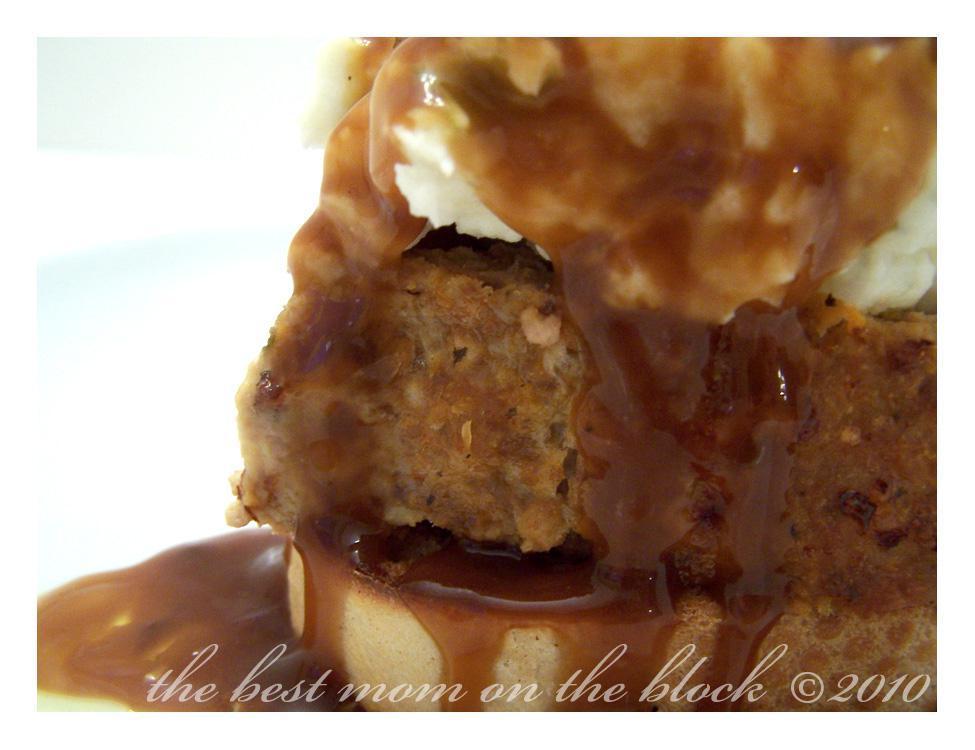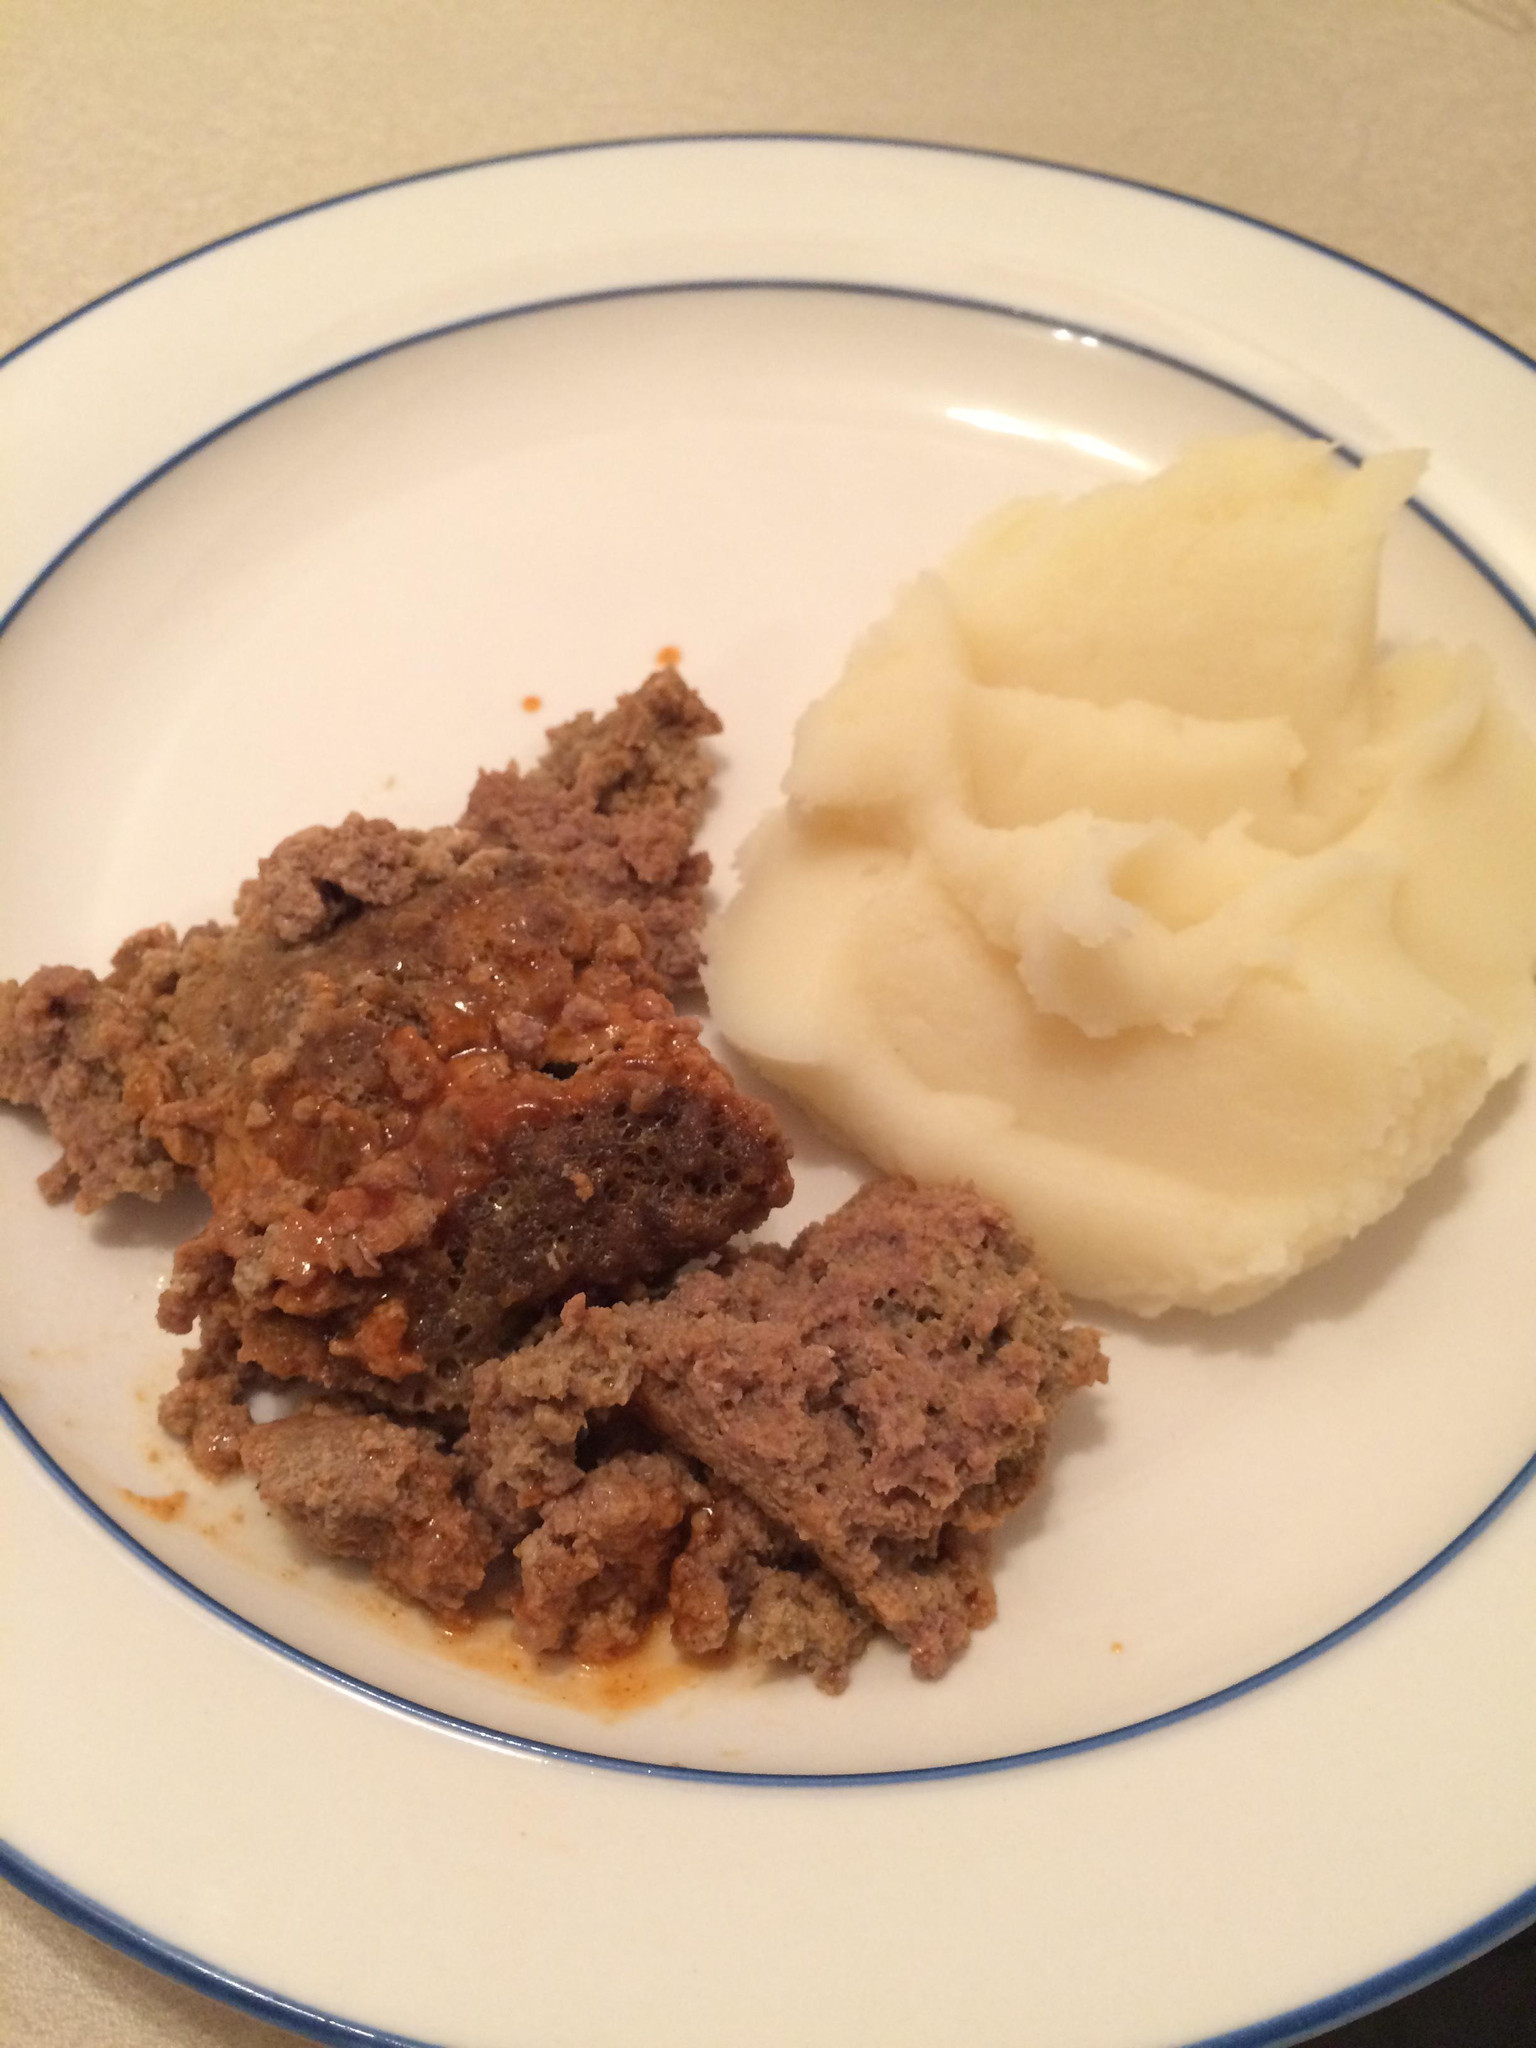The first image is the image on the left, the second image is the image on the right. Assess this claim about the two images: "A dish includes meatloaf topped with mashed potatoes and brown gravy.". Correct or not? Answer yes or no. Yes. The first image is the image on the left, the second image is the image on the right. For the images shown, is this caption "There is nothing on top of a mashed potato in the right image." true? Answer yes or no. Yes. 